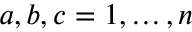<formula> <loc_0><loc_0><loc_500><loc_500>a , b , c = 1 , \dots , n</formula> 